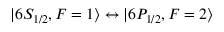Convert formula to latex. <formula><loc_0><loc_0><loc_500><loc_500>| 6 S _ { 1 / 2 } , F = 1 \rangle \leftrightarrow | 6 P _ { 1 / 2 } , F = 2 \rangle</formula> 